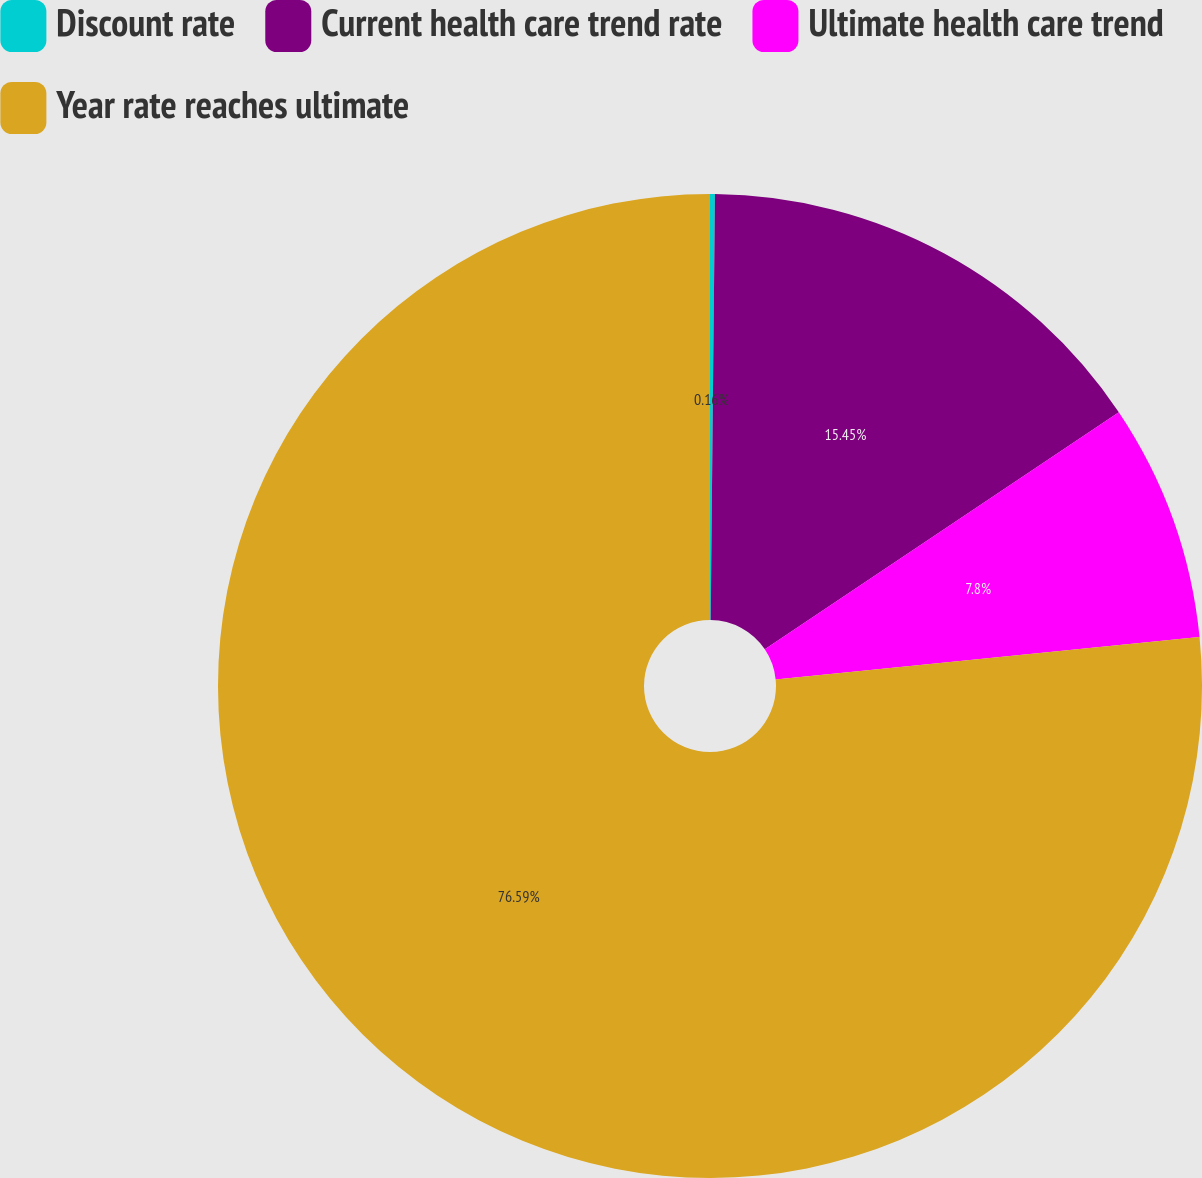Convert chart. <chart><loc_0><loc_0><loc_500><loc_500><pie_chart><fcel>Discount rate<fcel>Current health care trend rate<fcel>Ultimate health care trend<fcel>Year rate reaches ultimate<nl><fcel>0.16%<fcel>15.45%<fcel>7.8%<fcel>76.59%<nl></chart> 